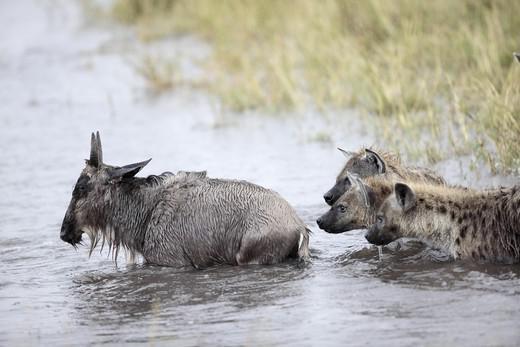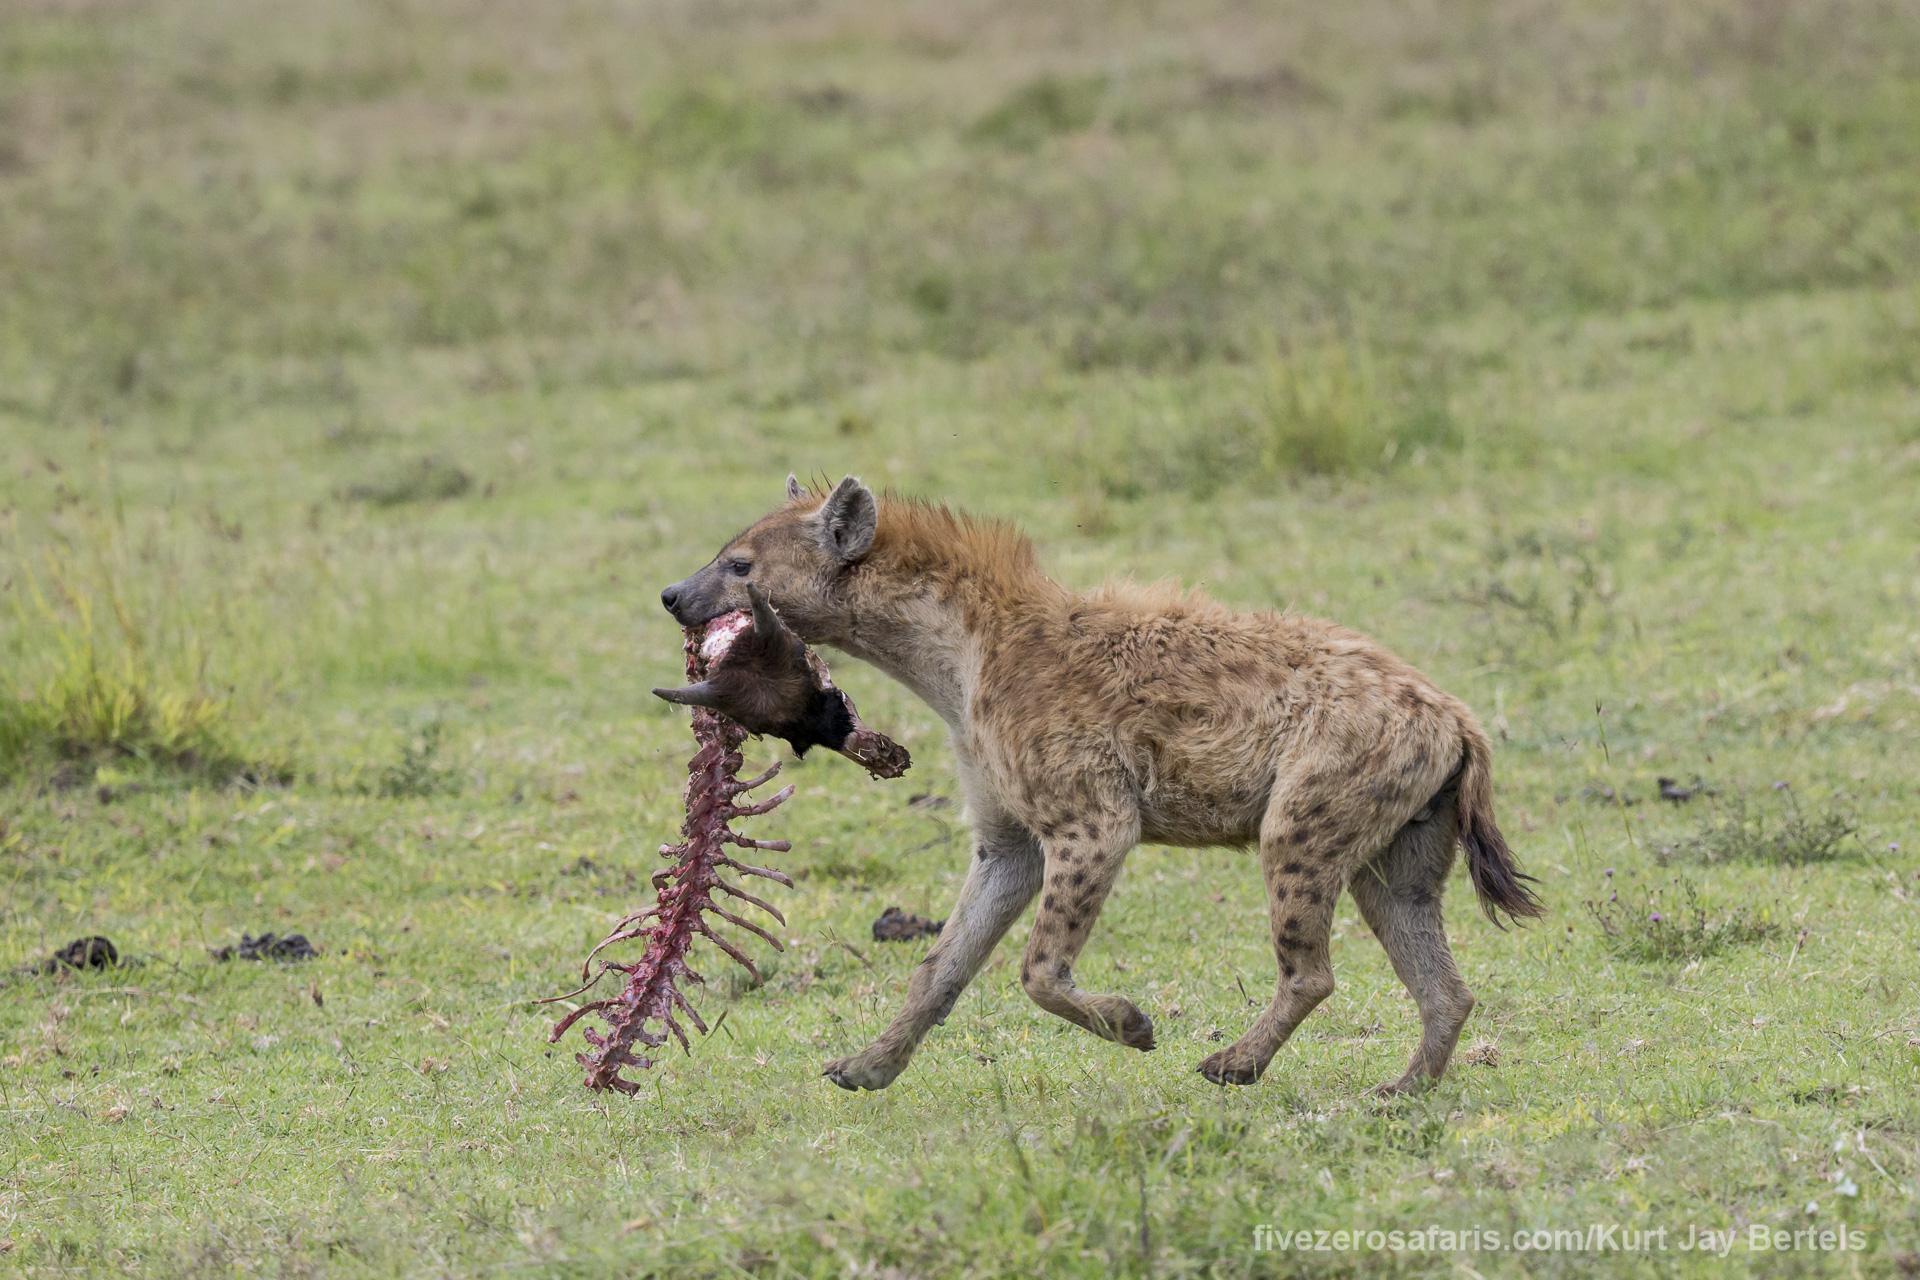The first image is the image on the left, the second image is the image on the right. Evaluate the accuracy of this statement regarding the images: "The left image shows one hyena facing away from the camera and standing next to a downed horned animal that is larger than the hyena.". Is it true? Answer yes or no. No. The first image is the image on the left, the second image is the image on the right. Given the left and right images, does the statement "The right image contains no more than two hyenas." hold true? Answer yes or no. Yes. 